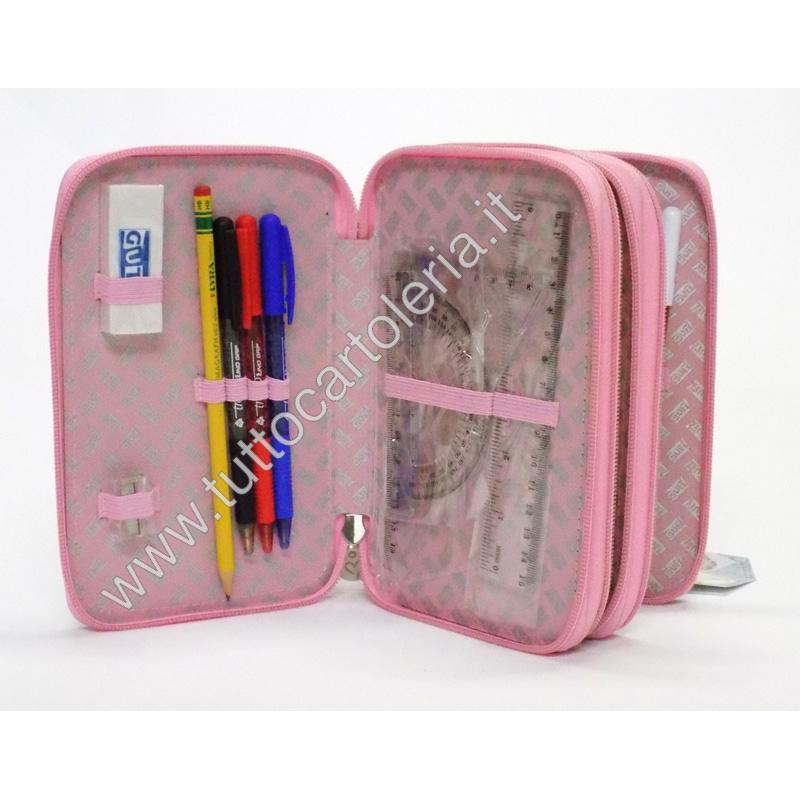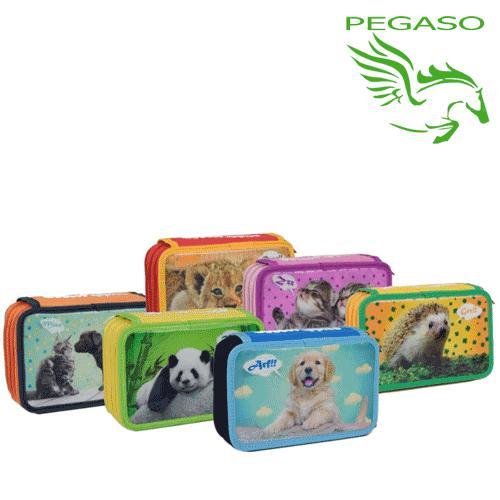The first image is the image on the left, the second image is the image on the right. Analyze the images presented: Is the assertion "There are writing utensils visible in one of the images." valid? Answer yes or no. Yes. The first image is the image on the left, the second image is the image on the right. Given the left and right images, does the statement "The case in one of the images is opened to reveal its contents." hold true? Answer yes or no. Yes. 